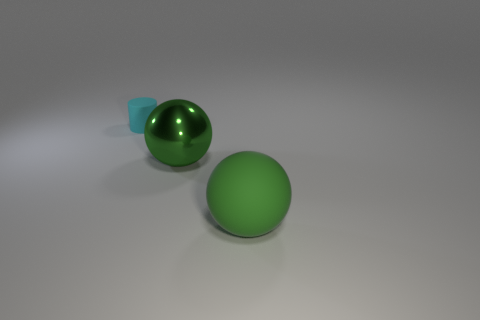Add 2 purple rubber cubes. How many objects exist? 5 Subtract all cylinders. How many objects are left? 2 Add 3 rubber things. How many rubber things exist? 5 Subtract 0 green cylinders. How many objects are left? 3 Subtract 1 balls. How many balls are left? 1 Subtract all purple cylinders. Subtract all cyan spheres. How many cylinders are left? 1 Subtract all gray cylinders. How many gray spheres are left? 0 Subtract all matte cylinders. Subtract all rubber cylinders. How many objects are left? 1 Add 1 big objects. How many big objects are left? 3 